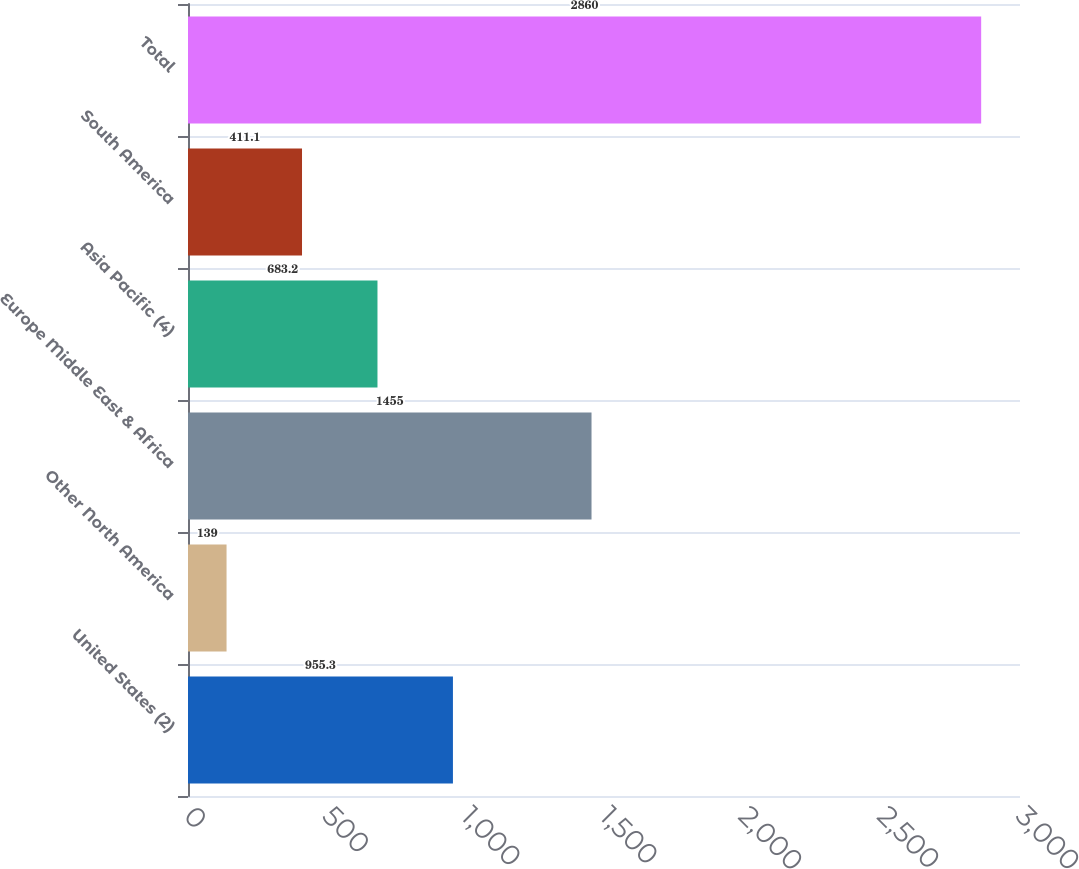<chart> <loc_0><loc_0><loc_500><loc_500><bar_chart><fcel>United States (2)<fcel>Other North America<fcel>Europe Middle East & Africa<fcel>Asia Pacific (4)<fcel>South America<fcel>Total<nl><fcel>955.3<fcel>139<fcel>1455<fcel>683.2<fcel>411.1<fcel>2860<nl></chart> 